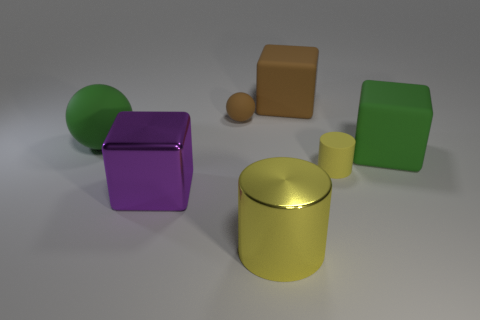Are there any small rubber cylinders that have the same color as the metal cylinder?
Offer a terse response. Yes. How many rubber objects have the same color as the tiny matte ball?
Your answer should be very brief. 1. Do the tiny matte ball and the large object that is behind the small matte ball have the same color?
Offer a very short reply. Yes. Is there anything else that has the same color as the shiny cylinder?
Your answer should be compact. Yes. Are there any green rubber objects of the same shape as the large brown object?
Ensure brevity in your answer.  Yes. There is a matte cube on the right side of the brown cube; what size is it?
Give a very brief answer. Large. Is the rubber cylinder the same size as the metallic cylinder?
Make the answer very short. No. Are there fewer green matte cubes right of the green block than big purple objects that are on the right side of the big green ball?
Keep it short and to the point. Yes. There is a object that is both in front of the large green matte block and behind the large purple metallic object; what size is it?
Ensure brevity in your answer.  Small. Is there a yellow rubber cylinder on the left side of the tiny matte thing left of the yellow cylinder that is in front of the big purple block?
Your response must be concise. No. 